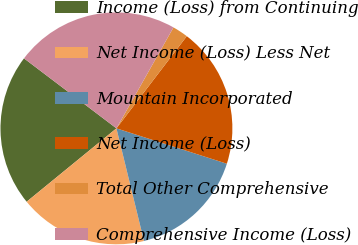Convert chart to OTSL. <chart><loc_0><loc_0><loc_500><loc_500><pie_chart><fcel>Income (Loss) from Continuing<fcel>Net Income (Loss) Less Net<fcel>Mountain Incorporated<fcel>Net Income (Loss)<fcel>Total Other Comprehensive<fcel>Comprehensive Income (Loss)<nl><fcel>21.22%<fcel>17.91%<fcel>16.25%<fcel>19.56%<fcel>2.19%<fcel>22.87%<nl></chart> 